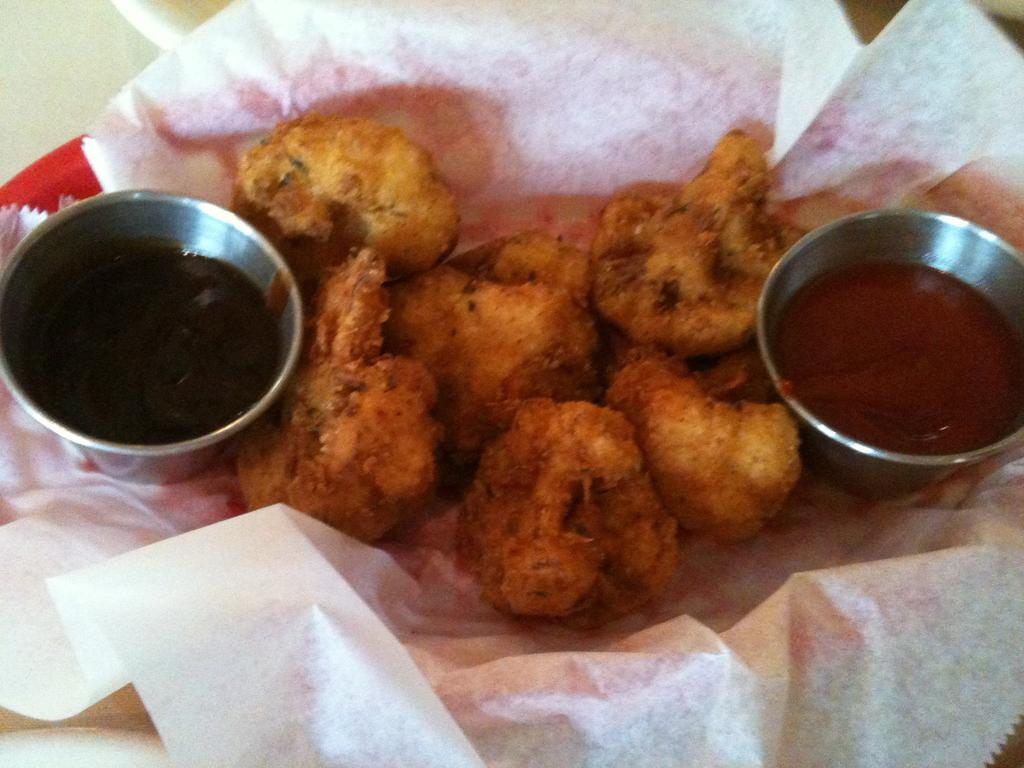What is placed on the paper in the image? There is a food item on the paper. How many types of sauces are present in the image? There are two different types of sauces in the bowls. Where are the bowls located in relation to the paper? The bowls are on the paper. What is the surface that the bowls and paper are placed on? The bowls and paper are placed on a plate. What type of competition is taking place between the bushes in the image? There are no bushes present in the image, so it is not possible to determine if a competition is taking place. 